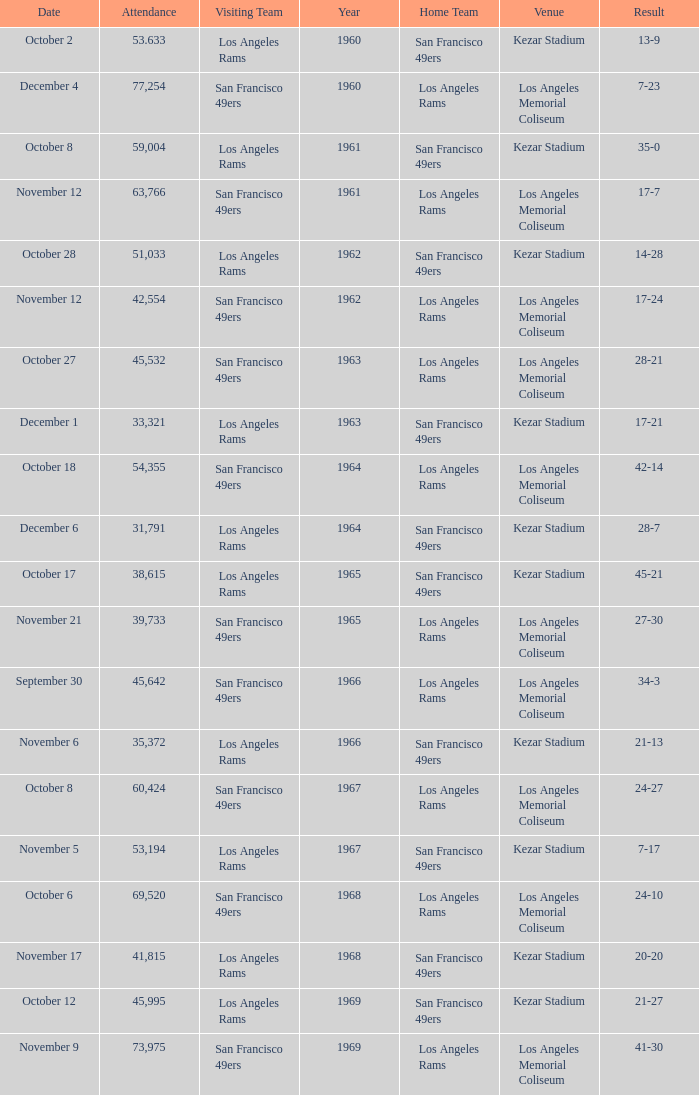When was the earliest year when the attendance was 77,254? 1960.0. 